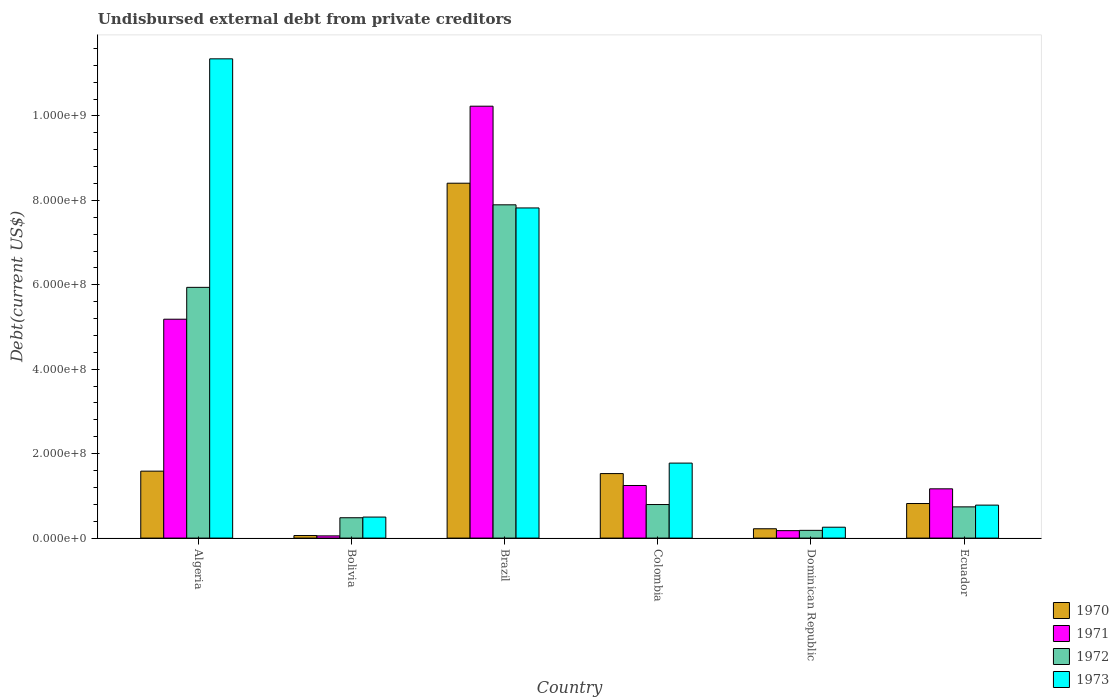How many groups of bars are there?
Your response must be concise. 6. Are the number of bars per tick equal to the number of legend labels?
Provide a succinct answer. Yes. Are the number of bars on each tick of the X-axis equal?
Offer a terse response. Yes. In how many cases, is the number of bars for a given country not equal to the number of legend labels?
Make the answer very short. 0. What is the total debt in 1972 in Algeria?
Keep it short and to the point. 5.94e+08. Across all countries, what is the maximum total debt in 1973?
Your answer should be compact. 1.14e+09. Across all countries, what is the minimum total debt in 1973?
Offer a very short reply. 2.58e+07. In which country was the total debt in 1971 minimum?
Your answer should be compact. Bolivia. What is the total total debt in 1973 in the graph?
Offer a very short reply. 2.25e+09. What is the difference between the total debt in 1973 in Algeria and that in Brazil?
Make the answer very short. 3.53e+08. What is the difference between the total debt in 1970 in Ecuador and the total debt in 1971 in Colombia?
Ensure brevity in your answer.  -4.27e+07. What is the average total debt in 1973 per country?
Provide a succinct answer. 3.75e+08. What is the difference between the total debt of/in 1973 and total debt of/in 1970 in Colombia?
Keep it short and to the point. 2.48e+07. What is the ratio of the total debt in 1971 in Algeria to that in Brazil?
Offer a very short reply. 0.51. What is the difference between the highest and the second highest total debt in 1971?
Offer a terse response. 8.98e+08. What is the difference between the highest and the lowest total debt in 1973?
Your answer should be compact. 1.11e+09. Is the sum of the total debt in 1971 in Brazil and Colombia greater than the maximum total debt in 1972 across all countries?
Give a very brief answer. Yes. Is it the case that in every country, the sum of the total debt in 1972 and total debt in 1971 is greater than the sum of total debt in 1973 and total debt in 1970?
Ensure brevity in your answer.  No. What does the 3rd bar from the right in Colombia represents?
Your answer should be very brief. 1971. How many bars are there?
Give a very brief answer. 24. Are all the bars in the graph horizontal?
Keep it short and to the point. No. What is the difference between two consecutive major ticks on the Y-axis?
Give a very brief answer. 2.00e+08. Are the values on the major ticks of Y-axis written in scientific E-notation?
Provide a succinct answer. Yes. Does the graph contain grids?
Your answer should be very brief. No. What is the title of the graph?
Make the answer very short. Undisbursed external debt from private creditors. What is the label or title of the X-axis?
Ensure brevity in your answer.  Country. What is the label or title of the Y-axis?
Offer a terse response. Debt(current US$). What is the Debt(current US$) of 1970 in Algeria?
Your answer should be very brief. 1.59e+08. What is the Debt(current US$) of 1971 in Algeria?
Give a very brief answer. 5.18e+08. What is the Debt(current US$) in 1972 in Algeria?
Make the answer very short. 5.94e+08. What is the Debt(current US$) in 1973 in Algeria?
Provide a short and direct response. 1.14e+09. What is the Debt(current US$) in 1970 in Bolivia?
Keep it short and to the point. 6.05e+06. What is the Debt(current US$) of 1971 in Bolivia?
Your response must be concise. 5.25e+06. What is the Debt(current US$) of 1972 in Bolivia?
Provide a short and direct response. 4.82e+07. What is the Debt(current US$) of 1973 in Bolivia?
Offer a terse response. 4.98e+07. What is the Debt(current US$) in 1970 in Brazil?
Offer a terse response. 8.41e+08. What is the Debt(current US$) in 1971 in Brazil?
Your answer should be very brief. 1.02e+09. What is the Debt(current US$) of 1972 in Brazil?
Offer a terse response. 7.89e+08. What is the Debt(current US$) of 1973 in Brazil?
Your response must be concise. 7.82e+08. What is the Debt(current US$) in 1970 in Colombia?
Provide a short and direct response. 1.53e+08. What is the Debt(current US$) in 1971 in Colombia?
Keep it short and to the point. 1.25e+08. What is the Debt(current US$) in 1972 in Colombia?
Give a very brief answer. 7.95e+07. What is the Debt(current US$) in 1973 in Colombia?
Your answer should be very brief. 1.78e+08. What is the Debt(current US$) of 1970 in Dominican Republic?
Keep it short and to the point. 2.21e+07. What is the Debt(current US$) in 1971 in Dominican Republic?
Your response must be concise. 1.76e+07. What is the Debt(current US$) of 1972 in Dominican Republic?
Offer a very short reply. 1.83e+07. What is the Debt(current US$) in 1973 in Dominican Republic?
Your response must be concise. 2.58e+07. What is the Debt(current US$) in 1970 in Ecuador?
Provide a short and direct response. 8.19e+07. What is the Debt(current US$) of 1971 in Ecuador?
Provide a short and direct response. 1.17e+08. What is the Debt(current US$) in 1972 in Ecuador?
Keep it short and to the point. 7.40e+07. What is the Debt(current US$) of 1973 in Ecuador?
Provide a succinct answer. 7.81e+07. Across all countries, what is the maximum Debt(current US$) in 1970?
Provide a succinct answer. 8.41e+08. Across all countries, what is the maximum Debt(current US$) of 1971?
Provide a short and direct response. 1.02e+09. Across all countries, what is the maximum Debt(current US$) of 1972?
Provide a succinct answer. 7.89e+08. Across all countries, what is the maximum Debt(current US$) of 1973?
Ensure brevity in your answer.  1.14e+09. Across all countries, what is the minimum Debt(current US$) of 1970?
Offer a terse response. 6.05e+06. Across all countries, what is the minimum Debt(current US$) of 1971?
Keep it short and to the point. 5.25e+06. Across all countries, what is the minimum Debt(current US$) of 1972?
Your answer should be compact. 1.83e+07. Across all countries, what is the minimum Debt(current US$) of 1973?
Ensure brevity in your answer.  2.58e+07. What is the total Debt(current US$) in 1970 in the graph?
Your answer should be very brief. 1.26e+09. What is the total Debt(current US$) in 1971 in the graph?
Provide a short and direct response. 1.81e+09. What is the total Debt(current US$) of 1972 in the graph?
Your response must be concise. 1.60e+09. What is the total Debt(current US$) of 1973 in the graph?
Offer a terse response. 2.25e+09. What is the difference between the Debt(current US$) of 1970 in Algeria and that in Bolivia?
Ensure brevity in your answer.  1.53e+08. What is the difference between the Debt(current US$) in 1971 in Algeria and that in Bolivia?
Give a very brief answer. 5.13e+08. What is the difference between the Debt(current US$) of 1972 in Algeria and that in Bolivia?
Keep it short and to the point. 5.46e+08. What is the difference between the Debt(current US$) in 1973 in Algeria and that in Bolivia?
Keep it short and to the point. 1.09e+09. What is the difference between the Debt(current US$) in 1970 in Algeria and that in Brazil?
Make the answer very short. -6.82e+08. What is the difference between the Debt(current US$) in 1971 in Algeria and that in Brazil?
Your answer should be very brief. -5.05e+08. What is the difference between the Debt(current US$) in 1972 in Algeria and that in Brazil?
Make the answer very short. -1.95e+08. What is the difference between the Debt(current US$) of 1973 in Algeria and that in Brazil?
Provide a succinct answer. 3.53e+08. What is the difference between the Debt(current US$) in 1970 in Algeria and that in Colombia?
Your answer should be compact. 5.77e+06. What is the difference between the Debt(current US$) of 1971 in Algeria and that in Colombia?
Give a very brief answer. 3.94e+08. What is the difference between the Debt(current US$) in 1972 in Algeria and that in Colombia?
Your response must be concise. 5.14e+08. What is the difference between the Debt(current US$) of 1973 in Algeria and that in Colombia?
Make the answer very short. 9.58e+08. What is the difference between the Debt(current US$) in 1970 in Algeria and that in Dominican Republic?
Your answer should be very brief. 1.36e+08. What is the difference between the Debt(current US$) of 1971 in Algeria and that in Dominican Republic?
Your response must be concise. 5.01e+08. What is the difference between the Debt(current US$) in 1972 in Algeria and that in Dominican Republic?
Ensure brevity in your answer.  5.76e+08. What is the difference between the Debt(current US$) of 1973 in Algeria and that in Dominican Republic?
Your answer should be very brief. 1.11e+09. What is the difference between the Debt(current US$) of 1970 in Algeria and that in Ecuador?
Make the answer very short. 7.67e+07. What is the difference between the Debt(current US$) in 1971 in Algeria and that in Ecuador?
Make the answer very short. 4.02e+08. What is the difference between the Debt(current US$) in 1972 in Algeria and that in Ecuador?
Your answer should be very brief. 5.20e+08. What is the difference between the Debt(current US$) of 1973 in Algeria and that in Ecuador?
Offer a terse response. 1.06e+09. What is the difference between the Debt(current US$) in 1970 in Bolivia and that in Brazil?
Provide a short and direct response. -8.35e+08. What is the difference between the Debt(current US$) in 1971 in Bolivia and that in Brazil?
Make the answer very short. -1.02e+09. What is the difference between the Debt(current US$) in 1972 in Bolivia and that in Brazil?
Keep it short and to the point. -7.41e+08. What is the difference between the Debt(current US$) of 1973 in Bolivia and that in Brazil?
Make the answer very short. -7.32e+08. What is the difference between the Debt(current US$) in 1970 in Bolivia and that in Colombia?
Make the answer very short. -1.47e+08. What is the difference between the Debt(current US$) in 1971 in Bolivia and that in Colombia?
Give a very brief answer. -1.19e+08. What is the difference between the Debt(current US$) of 1972 in Bolivia and that in Colombia?
Provide a short and direct response. -3.13e+07. What is the difference between the Debt(current US$) in 1973 in Bolivia and that in Colombia?
Keep it short and to the point. -1.28e+08. What is the difference between the Debt(current US$) of 1970 in Bolivia and that in Dominican Republic?
Your answer should be very brief. -1.60e+07. What is the difference between the Debt(current US$) in 1971 in Bolivia and that in Dominican Republic?
Provide a succinct answer. -1.24e+07. What is the difference between the Debt(current US$) of 1972 in Bolivia and that in Dominican Republic?
Ensure brevity in your answer.  2.99e+07. What is the difference between the Debt(current US$) of 1973 in Bolivia and that in Dominican Republic?
Offer a very short reply. 2.40e+07. What is the difference between the Debt(current US$) of 1970 in Bolivia and that in Ecuador?
Provide a succinct answer. -7.58e+07. What is the difference between the Debt(current US$) in 1971 in Bolivia and that in Ecuador?
Offer a very short reply. -1.11e+08. What is the difference between the Debt(current US$) of 1972 in Bolivia and that in Ecuador?
Ensure brevity in your answer.  -2.58e+07. What is the difference between the Debt(current US$) in 1973 in Bolivia and that in Ecuador?
Your response must be concise. -2.83e+07. What is the difference between the Debt(current US$) of 1970 in Brazil and that in Colombia?
Ensure brevity in your answer.  6.88e+08. What is the difference between the Debt(current US$) in 1971 in Brazil and that in Colombia?
Ensure brevity in your answer.  8.98e+08. What is the difference between the Debt(current US$) of 1972 in Brazil and that in Colombia?
Make the answer very short. 7.10e+08. What is the difference between the Debt(current US$) of 1973 in Brazil and that in Colombia?
Keep it short and to the point. 6.04e+08. What is the difference between the Debt(current US$) in 1970 in Brazil and that in Dominican Republic?
Ensure brevity in your answer.  8.19e+08. What is the difference between the Debt(current US$) of 1971 in Brazil and that in Dominican Republic?
Offer a very short reply. 1.01e+09. What is the difference between the Debt(current US$) of 1972 in Brazil and that in Dominican Republic?
Provide a short and direct response. 7.71e+08. What is the difference between the Debt(current US$) in 1973 in Brazil and that in Dominican Republic?
Your answer should be compact. 7.56e+08. What is the difference between the Debt(current US$) of 1970 in Brazil and that in Ecuador?
Give a very brief answer. 7.59e+08. What is the difference between the Debt(current US$) in 1971 in Brazil and that in Ecuador?
Offer a very short reply. 9.06e+08. What is the difference between the Debt(current US$) in 1972 in Brazil and that in Ecuador?
Your answer should be very brief. 7.15e+08. What is the difference between the Debt(current US$) of 1973 in Brazil and that in Ecuador?
Provide a short and direct response. 7.04e+08. What is the difference between the Debt(current US$) in 1970 in Colombia and that in Dominican Republic?
Offer a terse response. 1.31e+08. What is the difference between the Debt(current US$) of 1971 in Colombia and that in Dominican Republic?
Offer a terse response. 1.07e+08. What is the difference between the Debt(current US$) in 1972 in Colombia and that in Dominican Republic?
Ensure brevity in your answer.  6.12e+07. What is the difference between the Debt(current US$) in 1973 in Colombia and that in Dominican Republic?
Give a very brief answer. 1.52e+08. What is the difference between the Debt(current US$) of 1970 in Colombia and that in Ecuador?
Your answer should be compact. 7.09e+07. What is the difference between the Debt(current US$) of 1971 in Colombia and that in Ecuador?
Ensure brevity in your answer.  7.88e+06. What is the difference between the Debt(current US$) in 1972 in Colombia and that in Ecuador?
Provide a short and direct response. 5.49e+06. What is the difference between the Debt(current US$) of 1973 in Colombia and that in Ecuador?
Offer a very short reply. 9.95e+07. What is the difference between the Debt(current US$) in 1970 in Dominican Republic and that in Ecuador?
Keep it short and to the point. -5.98e+07. What is the difference between the Debt(current US$) in 1971 in Dominican Republic and that in Ecuador?
Provide a short and direct response. -9.91e+07. What is the difference between the Debt(current US$) of 1972 in Dominican Republic and that in Ecuador?
Offer a terse response. -5.57e+07. What is the difference between the Debt(current US$) of 1973 in Dominican Republic and that in Ecuador?
Offer a terse response. -5.23e+07. What is the difference between the Debt(current US$) of 1970 in Algeria and the Debt(current US$) of 1971 in Bolivia?
Ensure brevity in your answer.  1.53e+08. What is the difference between the Debt(current US$) in 1970 in Algeria and the Debt(current US$) in 1972 in Bolivia?
Give a very brief answer. 1.10e+08. What is the difference between the Debt(current US$) in 1970 in Algeria and the Debt(current US$) in 1973 in Bolivia?
Your answer should be compact. 1.09e+08. What is the difference between the Debt(current US$) in 1971 in Algeria and the Debt(current US$) in 1972 in Bolivia?
Your answer should be very brief. 4.70e+08. What is the difference between the Debt(current US$) in 1971 in Algeria and the Debt(current US$) in 1973 in Bolivia?
Provide a short and direct response. 4.69e+08. What is the difference between the Debt(current US$) of 1972 in Algeria and the Debt(current US$) of 1973 in Bolivia?
Your answer should be very brief. 5.44e+08. What is the difference between the Debt(current US$) of 1970 in Algeria and the Debt(current US$) of 1971 in Brazil?
Your response must be concise. -8.64e+08. What is the difference between the Debt(current US$) in 1970 in Algeria and the Debt(current US$) in 1972 in Brazil?
Your response must be concise. -6.31e+08. What is the difference between the Debt(current US$) of 1970 in Algeria and the Debt(current US$) of 1973 in Brazil?
Offer a very short reply. -6.23e+08. What is the difference between the Debt(current US$) of 1971 in Algeria and the Debt(current US$) of 1972 in Brazil?
Offer a very short reply. -2.71e+08. What is the difference between the Debt(current US$) of 1971 in Algeria and the Debt(current US$) of 1973 in Brazil?
Provide a succinct answer. -2.64e+08. What is the difference between the Debt(current US$) of 1972 in Algeria and the Debt(current US$) of 1973 in Brazil?
Ensure brevity in your answer.  -1.88e+08. What is the difference between the Debt(current US$) in 1970 in Algeria and the Debt(current US$) in 1971 in Colombia?
Offer a very short reply. 3.40e+07. What is the difference between the Debt(current US$) in 1970 in Algeria and the Debt(current US$) in 1972 in Colombia?
Give a very brief answer. 7.91e+07. What is the difference between the Debt(current US$) in 1970 in Algeria and the Debt(current US$) in 1973 in Colombia?
Make the answer very short. -1.90e+07. What is the difference between the Debt(current US$) in 1971 in Algeria and the Debt(current US$) in 1972 in Colombia?
Give a very brief answer. 4.39e+08. What is the difference between the Debt(current US$) of 1971 in Algeria and the Debt(current US$) of 1973 in Colombia?
Give a very brief answer. 3.41e+08. What is the difference between the Debt(current US$) of 1972 in Algeria and the Debt(current US$) of 1973 in Colombia?
Ensure brevity in your answer.  4.16e+08. What is the difference between the Debt(current US$) of 1970 in Algeria and the Debt(current US$) of 1971 in Dominican Republic?
Offer a very short reply. 1.41e+08. What is the difference between the Debt(current US$) in 1970 in Algeria and the Debt(current US$) in 1972 in Dominican Republic?
Ensure brevity in your answer.  1.40e+08. What is the difference between the Debt(current US$) in 1970 in Algeria and the Debt(current US$) in 1973 in Dominican Republic?
Provide a succinct answer. 1.33e+08. What is the difference between the Debt(current US$) in 1971 in Algeria and the Debt(current US$) in 1972 in Dominican Republic?
Keep it short and to the point. 5.00e+08. What is the difference between the Debt(current US$) of 1971 in Algeria and the Debt(current US$) of 1973 in Dominican Republic?
Provide a succinct answer. 4.93e+08. What is the difference between the Debt(current US$) of 1972 in Algeria and the Debt(current US$) of 1973 in Dominican Republic?
Ensure brevity in your answer.  5.68e+08. What is the difference between the Debt(current US$) of 1970 in Algeria and the Debt(current US$) of 1971 in Ecuador?
Offer a very short reply. 4.18e+07. What is the difference between the Debt(current US$) in 1970 in Algeria and the Debt(current US$) in 1972 in Ecuador?
Make the answer very short. 8.46e+07. What is the difference between the Debt(current US$) of 1970 in Algeria and the Debt(current US$) of 1973 in Ecuador?
Ensure brevity in your answer.  8.05e+07. What is the difference between the Debt(current US$) in 1971 in Algeria and the Debt(current US$) in 1972 in Ecuador?
Keep it short and to the point. 4.44e+08. What is the difference between the Debt(current US$) in 1971 in Algeria and the Debt(current US$) in 1973 in Ecuador?
Give a very brief answer. 4.40e+08. What is the difference between the Debt(current US$) of 1972 in Algeria and the Debt(current US$) of 1973 in Ecuador?
Offer a very short reply. 5.16e+08. What is the difference between the Debt(current US$) of 1970 in Bolivia and the Debt(current US$) of 1971 in Brazil?
Ensure brevity in your answer.  -1.02e+09. What is the difference between the Debt(current US$) of 1970 in Bolivia and the Debt(current US$) of 1972 in Brazil?
Provide a succinct answer. -7.83e+08. What is the difference between the Debt(current US$) in 1970 in Bolivia and the Debt(current US$) in 1973 in Brazil?
Provide a short and direct response. -7.76e+08. What is the difference between the Debt(current US$) in 1971 in Bolivia and the Debt(current US$) in 1972 in Brazil?
Your answer should be compact. -7.84e+08. What is the difference between the Debt(current US$) of 1971 in Bolivia and the Debt(current US$) of 1973 in Brazil?
Make the answer very short. -7.77e+08. What is the difference between the Debt(current US$) in 1972 in Bolivia and the Debt(current US$) in 1973 in Brazil?
Provide a short and direct response. -7.34e+08. What is the difference between the Debt(current US$) of 1970 in Bolivia and the Debt(current US$) of 1971 in Colombia?
Provide a short and direct response. -1.19e+08. What is the difference between the Debt(current US$) in 1970 in Bolivia and the Debt(current US$) in 1972 in Colombia?
Provide a succinct answer. -7.34e+07. What is the difference between the Debt(current US$) in 1970 in Bolivia and the Debt(current US$) in 1973 in Colombia?
Give a very brief answer. -1.72e+08. What is the difference between the Debt(current US$) in 1971 in Bolivia and the Debt(current US$) in 1972 in Colombia?
Your answer should be very brief. -7.42e+07. What is the difference between the Debt(current US$) of 1971 in Bolivia and the Debt(current US$) of 1973 in Colombia?
Provide a succinct answer. -1.72e+08. What is the difference between the Debt(current US$) in 1972 in Bolivia and the Debt(current US$) in 1973 in Colombia?
Offer a very short reply. -1.29e+08. What is the difference between the Debt(current US$) in 1970 in Bolivia and the Debt(current US$) in 1971 in Dominican Republic?
Offer a terse response. -1.16e+07. What is the difference between the Debt(current US$) of 1970 in Bolivia and the Debt(current US$) of 1972 in Dominican Republic?
Your answer should be compact. -1.23e+07. What is the difference between the Debt(current US$) of 1970 in Bolivia and the Debt(current US$) of 1973 in Dominican Republic?
Offer a terse response. -1.97e+07. What is the difference between the Debt(current US$) in 1971 in Bolivia and the Debt(current US$) in 1972 in Dominican Republic?
Offer a terse response. -1.31e+07. What is the difference between the Debt(current US$) of 1971 in Bolivia and the Debt(current US$) of 1973 in Dominican Republic?
Your answer should be very brief. -2.05e+07. What is the difference between the Debt(current US$) of 1972 in Bolivia and the Debt(current US$) of 1973 in Dominican Republic?
Your answer should be compact. 2.24e+07. What is the difference between the Debt(current US$) of 1970 in Bolivia and the Debt(current US$) of 1971 in Ecuador?
Keep it short and to the point. -1.11e+08. What is the difference between the Debt(current US$) of 1970 in Bolivia and the Debt(current US$) of 1972 in Ecuador?
Keep it short and to the point. -6.79e+07. What is the difference between the Debt(current US$) of 1970 in Bolivia and the Debt(current US$) of 1973 in Ecuador?
Your answer should be compact. -7.21e+07. What is the difference between the Debt(current US$) of 1971 in Bolivia and the Debt(current US$) of 1972 in Ecuador?
Offer a very short reply. -6.87e+07. What is the difference between the Debt(current US$) in 1971 in Bolivia and the Debt(current US$) in 1973 in Ecuador?
Provide a short and direct response. -7.29e+07. What is the difference between the Debt(current US$) in 1972 in Bolivia and the Debt(current US$) in 1973 in Ecuador?
Ensure brevity in your answer.  -2.99e+07. What is the difference between the Debt(current US$) in 1970 in Brazil and the Debt(current US$) in 1971 in Colombia?
Your answer should be very brief. 7.16e+08. What is the difference between the Debt(current US$) in 1970 in Brazil and the Debt(current US$) in 1972 in Colombia?
Your response must be concise. 7.61e+08. What is the difference between the Debt(current US$) of 1970 in Brazil and the Debt(current US$) of 1973 in Colombia?
Provide a short and direct response. 6.63e+08. What is the difference between the Debt(current US$) in 1971 in Brazil and the Debt(current US$) in 1972 in Colombia?
Keep it short and to the point. 9.44e+08. What is the difference between the Debt(current US$) in 1971 in Brazil and the Debt(current US$) in 1973 in Colombia?
Give a very brief answer. 8.45e+08. What is the difference between the Debt(current US$) in 1972 in Brazil and the Debt(current US$) in 1973 in Colombia?
Provide a short and direct response. 6.12e+08. What is the difference between the Debt(current US$) in 1970 in Brazil and the Debt(current US$) in 1971 in Dominican Republic?
Your answer should be compact. 8.23e+08. What is the difference between the Debt(current US$) of 1970 in Brazil and the Debt(current US$) of 1972 in Dominican Republic?
Your answer should be very brief. 8.22e+08. What is the difference between the Debt(current US$) of 1970 in Brazil and the Debt(current US$) of 1973 in Dominican Republic?
Your answer should be very brief. 8.15e+08. What is the difference between the Debt(current US$) in 1971 in Brazil and the Debt(current US$) in 1972 in Dominican Republic?
Offer a very short reply. 1.00e+09. What is the difference between the Debt(current US$) of 1971 in Brazil and the Debt(current US$) of 1973 in Dominican Republic?
Your answer should be compact. 9.97e+08. What is the difference between the Debt(current US$) in 1972 in Brazil and the Debt(current US$) in 1973 in Dominican Republic?
Your answer should be very brief. 7.64e+08. What is the difference between the Debt(current US$) of 1970 in Brazil and the Debt(current US$) of 1971 in Ecuador?
Your answer should be very brief. 7.24e+08. What is the difference between the Debt(current US$) in 1970 in Brazil and the Debt(current US$) in 1972 in Ecuador?
Your response must be concise. 7.67e+08. What is the difference between the Debt(current US$) in 1970 in Brazil and the Debt(current US$) in 1973 in Ecuador?
Keep it short and to the point. 7.63e+08. What is the difference between the Debt(current US$) of 1971 in Brazil and the Debt(current US$) of 1972 in Ecuador?
Provide a short and direct response. 9.49e+08. What is the difference between the Debt(current US$) of 1971 in Brazil and the Debt(current US$) of 1973 in Ecuador?
Keep it short and to the point. 9.45e+08. What is the difference between the Debt(current US$) of 1972 in Brazil and the Debt(current US$) of 1973 in Ecuador?
Your answer should be compact. 7.11e+08. What is the difference between the Debt(current US$) in 1970 in Colombia and the Debt(current US$) in 1971 in Dominican Republic?
Provide a short and direct response. 1.35e+08. What is the difference between the Debt(current US$) in 1970 in Colombia and the Debt(current US$) in 1972 in Dominican Republic?
Offer a terse response. 1.34e+08. What is the difference between the Debt(current US$) of 1970 in Colombia and the Debt(current US$) of 1973 in Dominican Republic?
Provide a succinct answer. 1.27e+08. What is the difference between the Debt(current US$) in 1971 in Colombia and the Debt(current US$) in 1972 in Dominican Republic?
Offer a very short reply. 1.06e+08. What is the difference between the Debt(current US$) in 1971 in Colombia and the Debt(current US$) in 1973 in Dominican Republic?
Offer a terse response. 9.88e+07. What is the difference between the Debt(current US$) in 1972 in Colombia and the Debt(current US$) in 1973 in Dominican Republic?
Offer a very short reply. 5.37e+07. What is the difference between the Debt(current US$) of 1970 in Colombia and the Debt(current US$) of 1971 in Ecuador?
Give a very brief answer. 3.61e+07. What is the difference between the Debt(current US$) of 1970 in Colombia and the Debt(current US$) of 1972 in Ecuador?
Your answer should be compact. 7.88e+07. What is the difference between the Debt(current US$) of 1970 in Colombia and the Debt(current US$) of 1973 in Ecuador?
Provide a short and direct response. 7.47e+07. What is the difference between the Debt(current US$) of 1971 in Colombia and the Debt(current US$) of 1972 in Ecuador?
Your answer should be very brief. 5.06e+07. What is the difference between the Debt(current US$) of 1971 in Colombia and the Debt(current US$) of 1973 in Ecuador?
Provide a short and direct response. 4.65e+07. What is the difference between the Debt(current US$) of 1972 in Colombia and the Debt(current US$) of 1973 in Ecuador?
Offer a terse response. 1.36e+06. What is the difference between the Debt(current US$) of 1970 in Dominican Republic and the Debt(current US$) of 1971 in Ecuador?
Provide a short and direct response. -9.46e+07. What is the difference between the Debt(current US$) in 1970 in Dominican Republic and the Debt(current US$) in 1972 in Ecuador?
Offer a terse response. -5.19e+07. What is the difference between the Debt(current US$) of 1970 in Dominican Republic and the Debt(current US$) of 1973 in Ecuador?
Make the answer very short. -5.60e+07. What is the difference between the Debt(current US$) of 1971 in Dominican Republic and the Debt(current US$) of 1972 in Ecuador?
Offer a very short reply. -5.63e+07. What is the difference between the Debt(current US$) in 1971 in Dominican Republic and the Debt(current US$) in 1973 in Ecuador?
Your answer should be very brief. -6.05e+07. What is the difference between the Debt(current US$) in 1972 in Dominican Republic and the Debt(current US$) in 1973 in Ecuador?
Offer a terse response. -5.98e+07. What is the average Debt(current US$) of 1970 per country?
Give a very brief answer. 2.10e+08. What is the average Debt(current US$) in 1971 per country?
Keep it short and to the point. 3.01e+08. What is the average Debt(current US$) of 1972 per country?
Provide a short and direct response. 2.67e+08. What is the average Debt(current US$) in 1973 per country?
Provide a succinct answer. 3.75e+08. What is the difference between the Debt(current US$) of 1970 and Debt(current US$) of 1971 in Algeria?
Offer a very short reply. -3.60e+08. What is the difference between the Debt(current US$) of 1970 and Debt(current US$) of 1972 in Algeria?
Offer a terse response. -4.35e+08. What is the difference between the Debt(current US$) in 1970 and Debt(current US$) in 1973 in Algeria?
Provide a succinct answer. -9.77e+08. What is the difference between the Debt(current US$) of 1971 and Debt(current US$) of 1972 in Algeria?
Ensure brevity in your answer.  -7.55e+07. What is the difference between the Debt(current US$) of 1971 and Debt(current US$) of 1973 in Algeria?
Your answer should be compact. -6.17e+08. What is the difference between the Debt(current US$) in 1972 and Debt(current US$) in 1973 in Algeria?
Offer a very short reply. -5.41e+08. What is the difference between the Debt(current US$) in 1970 and Debt(current US$) in 1971 in Bolivia?
Provide a succinct answer. 8.02e+05. What is the difference between the Debt(current US$) of 1970 and Debt(current US$) of 1972 in Bolivia?
Your response must be concise. -4.22e+07. What is the difference between the Debt(current US$) in 1970 and Debt(current US$) in 1973 in Bolivia?
Provide a succinct answer. -4.37e+07. What is the difference between the Debt(current US$) in 1971 and Debt(current US$) in 1972 in Bolivia?
Your answer should be compact. -4.30e+07. What is the difference between the Debt(current US$) in 1971 and Debt(current US$) in 1973 in Bolivia?
Provide a succinct answer. -4.45e+07. What is the difference between the Debt(current US$) of 1972 and Debt(current US$) of 1973 in Bolivia?
Offer a terse response. -1.58e+06. What is the difference between the Debt(current US$) of 1970 and Debt(current US$) of 1971 in Brazil?
Offer a very short reply. -1.82e+08. What is the difference between the Debt(current US$) in 1970 and Debt(current US$) in 1972 in Brazil?
Make the answer very short. 5.12e+07. What is the difference between the Debt(current US$) of 1970 and Debt(current US$) of 1973 in Brazil?
Provide a succinct answer. 5.86e+07. What is the difference between the Debt(current US$) in 1971 and Debt(current US$) in 1972 in Brazil?
Make the answer very short. 2.34e+08. What is the difference between the Debt(current US$) in 1971 and Debt(current US$) in 1973 in Brazil?
Your answer should be very brief. 2.41e+08. What is the difference between the Debt(current US$) of 1972 and Debt(current US$) of 1973 in Brazil?
Provide a short and direct response. 7.41e+06. What is the difference between the Debt(current US$) in 1970 and Debt(current US$) in 1971 in Colombia?
Give a very brief answer. 2.82e+07. What is the difference between the Debt(current US$) in 1970 and Debt(current US$) in 1972 in Colombia?
Ensure brevity in your answer.  7.33e+07. What is the difference between the Debt(current US$) in 1970 and Debt(current US$) in 1973 in Colombia?
Ensure brevity in your answer.  -2.48e+07. What is the difference between the Debt(current US$) in 1971 and Debt(current US$) in 1972 in Colombia?
Your answer should be compact. 4.51e+07. What is the difference between the Debt(current US$) in 1971 and Debt(current US$) in 1973 in Colombia?
Keep it short and to the point. -5.30e+07. What is the difference between the Debt(current US$) in 1972 and Debt(current US$) in 1973 in Colombia?
Make the answer very short. -9.81e+07. What is the difference between the Debt(current US$) of 1970 and Debt(current US$) of 1971 in Dominican Republic?
Offer a terse response. 4.46e+06. What is the difference between the Debt(current US$) of 1970 and Debt(current US$) of 1972 in Dominican Republic?
Offer a very short reply. 3.78e+06. What is the difference between the Debt(current US$) in 1970 and Debt(current US$) in 1973 in Dominican Republic?
Offer a very short reply. -3.68e+06. What is the difference between the Debt(current US$) in 1971 and Debt(current US$) in 1972 in Dominican Republic?
Your answer should be compact. -6.84e+05. What is the difference between the Debt(current US$) in 1971 and Debt(current US$) in 1973 in Dominican Republic?
Provide a succinct answer. -8.14e+06. What is the difference between the Debt(current US$) of 1972 and Debt(current US$) of 1973 in Dominican Republic?
Provide a short and direct response. -7.46e+06. What is the difference between the Debt(current US$) of 1970 and Debt(current US$) of 1971 in Ecuador?
Your response must be concise. -3.48e+07. What is the difference between the Debt(current US$) in 1970 and Debt(current US$) in 1972 in Ecuador?
Give a very brief answer. 7.92e+06. What is the difference between the Debt(current US$) in 1970 and Debt(current US$) in 1973 in Ecuador?
Ensure brevity in your answer.  3.78e+06. What is the difference between the Debt(current US$) of 1971 and Debt(current US$) of 1972 in Ecuador?
Provide a succinct answer. 4.27e+07. What is the difference between the Debt(current US$) in 1971 and Debt(current US$) in 1973 in Ecuador?
Your answer should be very brief. 3.86e+07. What is the difference between the Debt(current US$) in 1972 and Debt(current US$) in 1973 in Ecuador?
Give a very brief answer. -4.14e+06. What is the ratio of the Debt(current US$) in 1970 in Algeria to that in Bolivia?
Your response must be concise. 26.22. What is the ratio of the Debt(current US$) of 1971 in Algeria to that in Bolivia?
Provide a short and direct response. 98.83. What is the ratio of the Debt(current US$) of 1972 in Algeria to that in Bolivia?
Make the answer very short. 12.32. What is the ratio of the Debt(current US$) in 1973 in Algeria to that in Bolivia?
Your answer should be compact. 22.8. What is the ratio of the Debt(current US$) of 1970 in Algeria to that in Brazil?
Provide a succinct answer. 0.19. What is the ratio of the Debt(current US$) in 1971 in Algeria to that in Brazil?
Your answer should be compact. 0.51. What is the ratio of the Debt(current US$) of 1972 in Algeria to that in Brazil?
Your answer should be very brief. 0.75. What is the ratio of the Debt(current US$) of 1973 in Algeria to that in Brazil?
Keep it short and to the point. 1.45. What is the ratio of the Debt(current US$) of 1970 in Algeria to that in Colombia?
Your answer should be compact. 1.04. What is the ratio of the Debt(current US$) in 1971 in Algeria to that in Colombia?
Your response must be concise. 4.16. What is the ratio of the Debt(current US$) in 1972 in Algeria to that in Colombia?
Offer a terse response. 7.47. What is the ratio of the Debt(current US$) in 1973 in Algeria to that in Colombia?
Offer a terse response. 6.39. What is the ratio of the Debt(current US$) of 1970 in Algeria to that in Dominican Republic?
Offer a terse response. 7.18. What is the ratio of the Debt(current US$) of 1971 in Algeria to that in Dominican Republic?
Provide a succinct answer. 29.4. What is the ratio of the Debt(current US$) in 1972 in Algeria to that in Dominican Republic?
Give a very brief answer. 32.43. What is the ratio of the Debt(current US$) in 1973 in Algeria to that in Dominican Republic?
Ensure brevity in your answer.  44.05. What is the ratio of the Debt(current US$) of 1970 in Algeria to that in Ecuador?
Your answer should be compact. 1.94. What is the ratio of the Debt(current US$) of 1971 in Algeria to that in Ecuador?
Ensure brevity in your answer.  4.44. What is the ratio of the Debt(current US$) of 1972 in Algeria to that in Ecuador?
Ensure brevity in your answer.  8.03. What is the ratio of the Debt(current US$) of 1973 in Algeria to that in Ecuador?
Offer a very short reply. 14.53. What is the ratio of the Debt(current US$) of 1970 in Bolivia to that in Brazil?
Your answer should be very brief. 0.01. What is the ratio of the Debt(current US$) of 1971 in Bolivia to that in Brazil?
Make the answer very short. 0.01. What is the ratio of the Debt(current US$) in 1972 in Bolivia to that in Brazil?
Make the answer very short. 0.06. What is the ratio of the Debt(current US$) in 1973 in Bolivia to that in Brazil?
Your answer should be very brief. 0.06. What is the ratio of the Debt(current US$) in 1970 in Bolivia to that in Colombia?
Your response must be concise. 0.04. What is the ratio of the Debt(current US$) in 1971 in Bolivia to that in Colombia?
Ensure brevity in your answer.  0.04. What is the ratio of the Debt(current US$) of 1972 in Bolivia to that in Colombia?
Your answer should be compact. 0.61. What is the ratio of the Debt(current US$) of 1973 in Bolivia to that in Colombia?
Your answer should be compact. 0.28. What is the ratio of the Debt(current US$) in 1970 in Bolivia to that in Dominican Republic?
Offer a very short reply. 0.27. What is the ratio of the Debt(current US$) in 1971 in Bolivia to that in Dominican Republic?
Ensure brevity in your answer.  0.3. What is the ratio of the Debt(current US$) in 1972 in Bolivia to that in Dominican Republic?
Provide a succinct answer. 2.63. What is the ratio of the Debt(current US$) in 1973 in Bolivia to that in Dominican Republic?
Your answer should be very brief. 1.93. What is the ratio of the Debt(current US$) in 1970 in Bolivia to that in Ecuador?
Make the answer very short. 0.07. What is the ratio of the Debt(current US$) in 1971 in Bolivia to that in Ecuador?
Offer a very short reply. 0.04. What is the ratio of the Debt(current US$) in 1972 in Bolivia to that in Ecuador?
Offer a terse response. 0.65. What is the ratio of the Debt(current US$) in 1973 in Bolivia to that in Ecuador?
Your answer should be compact. 0.64. What is the ratio of the Debt(current US$) of 1970 in Brazil to that in Colombia?
Make the answer very short. 5.5. What is the ratio of the Debt(current US$) in 1971 in Brazil to that in Colombia?
Give a very brief answer. 8.21. What is the ratio of the Debt(current US$) of 1972 in Brazil to that in Colombia?
Provide a short and direct response. 9.93. What is the ratio of the Debt(current US$) of 1973 in Brazil to that in Colombia?
Give a very brief answer. 4.4. What is the ratio of the Debt(current US$) of 1970 in Brazil to that in Dominican Republic?
Give a very brief answer. 38.04. What is the ratio of the Debt(current US$) of 1971 in Brazil to that in Dominican Republic?
Offer a very short reply. 58.02. What is the ratio of the Debt(current US$) in 1972 in Brazil to that in Dominican Republic?
Ensure brevity in your answer.  43.1. What is the ratio of the Debt(current US$) of 1973 in Brazil to that in Dominican Republic?
Give a very brief answer. 30.34. What is the ratio of the Debt(current US$) in 1970 in Brazil to that in Ecuador?
Make the answer very short. 10.26. What is the ratio of the Debt(current US$) in 1971 in Brazil to that in Ecuador?
Your answer should be compact. 8.76. What is the ratio of the Debt(current US$) in 1972 in Brazil to that in Ecuador?
Provide a short and direct response. 10.67. What is the ratio of the Debt(current US$) of 1973 in Brazil to that in Ecuador?
Ensure brevity in your answer.  10.01. What is the ratio of the Debt(current US$) in 1970 in Colombia to that in Dominican Republic?
Keep it short and to the point. 6.92. What is the ratio of the Debt(current US$) in 1971 in Colombia to that in Dominican Republic?
Give a very brief answer. 7.07. What is the ratio of the Debt(current US$) in 1972 in Colombia to that in Dominican Republic?
Offer a terse response. 4.34. What is the ratio of the Debt(current US$) of 1973 in Colombia to that in Dominican Republic?
Your answer should be compact. 6.89. What is the ratio of the Debt(current US$) in 1970 in Colombia to that in Ecuador?
Your response must be concise. 1.87. What is the ratio of the Debt(current US$) in 1971 in Colombia to that in Ecuador?
Your answer should be very brief. 1.07. What is the ratio of the Debt(current US$) in 1972 in Colombia to that in Ecuador?
Offer a very short reply. 1.07. What is the ratio of the Debt(current US$) in 1973 in Colombia to that in Ecuador?
Offer a very short reply. 2.27. What is the ratio of the Debt(current US$) in 1970 in Dominican Republic to that in Ecuador?
Give a very brief answer. 0.27. What is the ratio of the Debt(current US$) in 1971 in Dominican Republic to that in Ecuador?
Give a very brief answer. 0.15. What is the ratio of the Debt(current US$) in 1972 in Dominican Republic to that in Ecuador?
Give a very brief answer. 0.25. What is the ratio of the Debt(current US$) of 1973 in Dominican Republic to that in Ecuador?
Make the answer very short. 0.33. What is the difference between the highest and the second highest Debt(current US$) in 1970?
Provide a succinct answer. 6.82e+08. What is the difference between the highest and the second highest Debt(current US$) of 1971?
Make the answer very short. 5.05e+08. What is the difference between the highest and the second highest Debt(current US$) of 1972?
Give a very brief answer. 1.95e+08. What is the difference between the highest and the second highest Debt(current US$) of 1973?
Provide a succinct answer. 3.53e+08. What is the difference between the highest and the lowest Debt(current US$) in 1970?
Your response must be concise. 8.35e+08. What is the difference between the highest and the lowest Debt(current US$) of 1971?
Offer a terse response. 1.02e+09. What is the difference between the highest and the lowest Debt(current US$) in 1972?
Your answer should be very brief. 7.71e+08. What is the difference between the highest and the lowest Debt(current US$) of 1973?
Provide a short and direct response. 1.11e+09. 